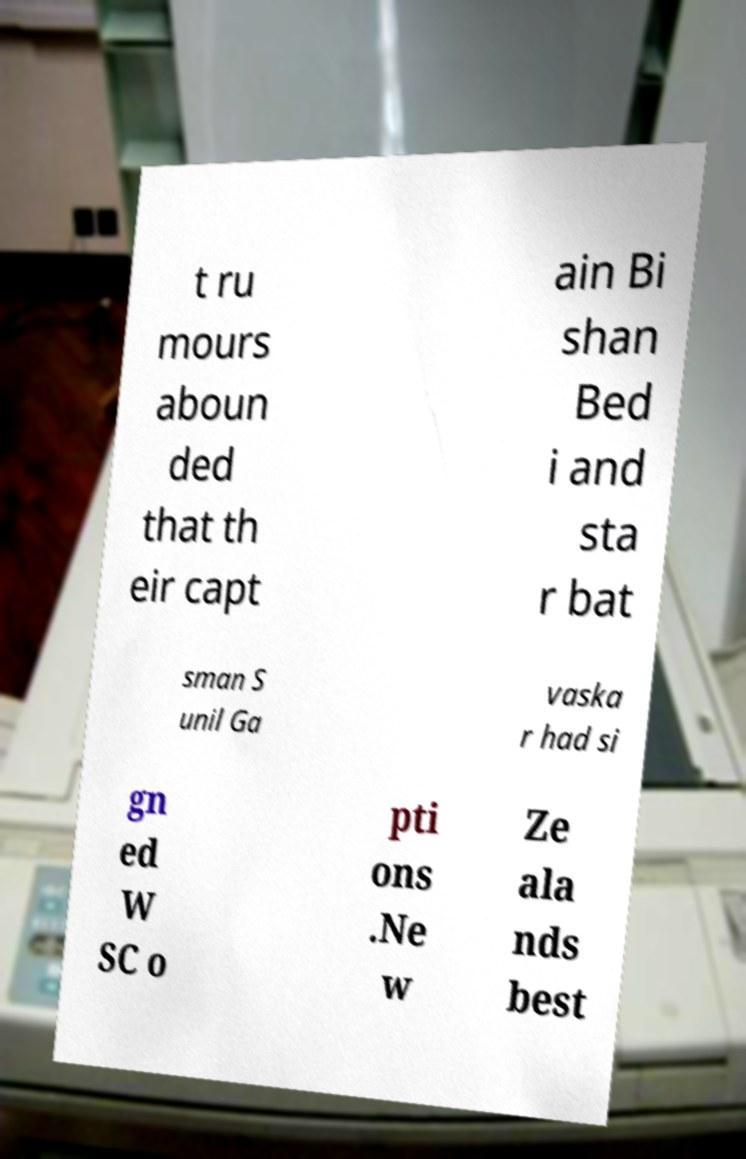I need the written content from this picture converted into text. Can you do that? t ru mours aboun ded that th eir capt ain Bi shan Bed i and sta r bat sman S unil Ga vaska r had si gn ed W SC o pti ons .Ne w Ze ala nds best 